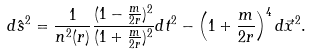<formula> <loc_0><loc_0><loc_500><loc_500>d \hat { s } ^ { 2 } = \frac { 1 } { n ^ { 2 } ( r ) } \frac { ( 1 - \frac { m } { 2 r } ) ^ { 2 } } { ( 1 + \frac { m } { 2 r } ) ^ { 2 } } d t ^ { 2 } - \left ( 1 + \frac { m } { 2 r } \right ) ^ { 4 } d \vec { x } ^ { 2 } .</formula> 